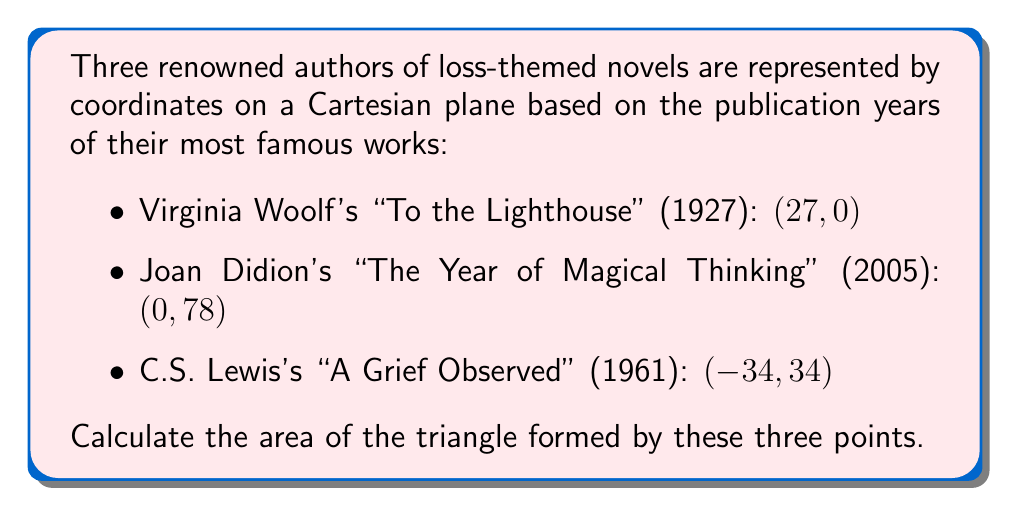Can you answer this question? To solve this problem, we'll use the formula for the area of a triangle given three points:

$$ \text{Area} = \frac{1}{2}|x_1(y_2 - y_3) + x_2(y_3 - y_1) + x_3(y_1 - y_2)| $$

Where $(x_1, y_1)$, $(x_2, y_2)$, and $(x_3, y_3)$ are the coordinates of the three points.

Let's assign our points:
$(x_1, y_1) = (27, 0)$ (Virginia Woolf)
$(x_2, y_2) = (0, 78)$ (Joan Didion)
$(x_3, y_3) = (-34, 34)$ (C.S. Lewis)

Now, let's substitute these values into our formula:

$$ \begin{align*}
\text{Area} &= \frac{1}{2}|27(78 - 34) + 0(34 - 0) + (-34)(0 - 78)| \\
&= \frac{1}{2}|27(44) + 0 + (-34)(-78)| \\
&= \frac{1}{2}|1188 + 0 + 2652| \\
&= \frac{1}{2}|3840| \\
&= \frac{1}{2}(3840) \\
&= 1920
\end{align*} $$

Therefore, the area of the triangle is 1920 square units.

[asy]
unitsize(2mm);
draw((-40,-10)--(40,90), gray);
draw((-40,0)--(40,0), gray);
draw((0,-10)--(0,90), gray);
draw((27,0)--(0,78)--(-34,34)--cycle, blue);
dot((27,0));
dot((0,78));
dot((-34,34));
label("Virginia Woolf (27, 0)", (27,0), S);
label("Joan Didion (0, 78)", (0,78), N);
label("C.S. Lewis (-34, 34)", (-34,34), W);
[/asy]
Answer: The area of the triangle is 1920 square units. 